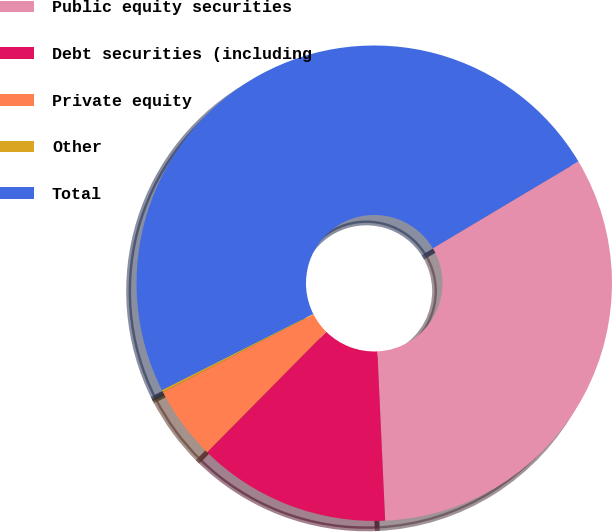Convert chart to OTSL. <chart><loc_0><loc_0><loc_500><loc_500><pie_chart><fcel>Public equity securities<fcel>Debt securities (including<fcel>Private equity<fcel>Other<fcel>Total<nl><fcel>32.83%<fcel>13.14%<fcel>5.02%<fcel>0.15%<fcel>48.86%<nl></chart> 